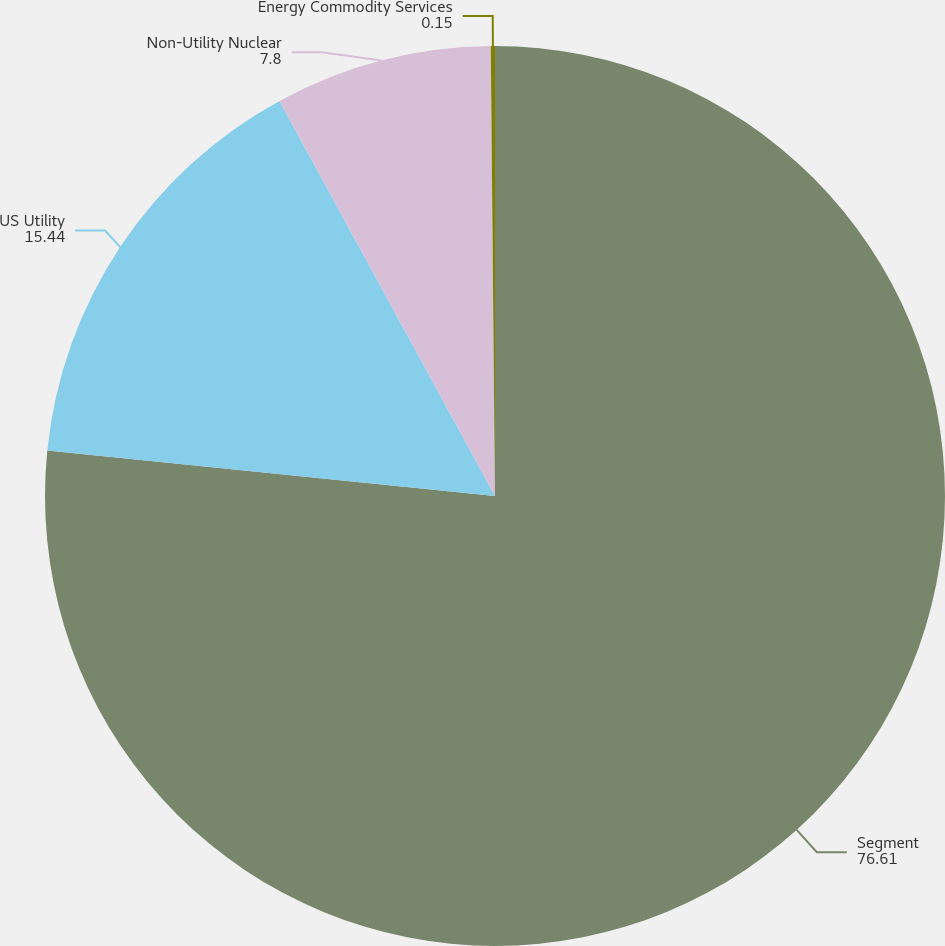Convert chart to OTSL. <chart><loc_0><loc_0><loc_500><loc_500><pie_chart><fcel>Segment<fcel>US Utility<fcel>Non-Utility Nuclear<fcel>Energy Commodity Services<nl><fcel>76.61%<fcel>15.44%<fcel>7.8%<fcel>0.15%<nl></chart> 